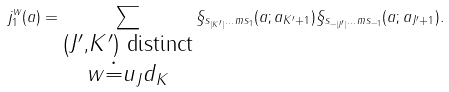Convert formula to latex. <formula><loc_0><loc_0><loc_500><loc_500>j _ { 1 } ^ { w } ( a ) = \sum _ { \substack { ( J ^ { \prime } , K ^ { \prime } ) \text { distinct} \\ w \doteq u _ { J } d _ { K } } } \S _ { s _ { | K ^ { \prime } | } \dots m s _ { 1 } } ( a ; a _ { K ^ { \prime } + 1 } ) \S _ { s _ { - | J ^ { \prime } | } \dots m s _ { - 1 } } ( a ; a _ { J ^ { \prime } + 1 } ) .</formula> 